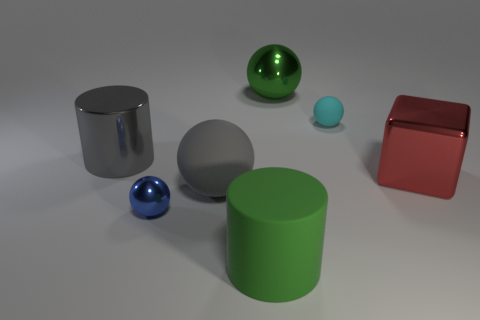Subtract all blue spheres. How many spheres are left? 3 Subtract all green spheres. How many spheres are left? 3 Subtract 1 cylinders. How many cylinders are left? 1 Subtract all blocks. How many objects are left? 6 Add 2 red matte things. How many objects exist? 9 Subtract all red cylinders. How many green spheres are left? 1 Subtract all large green spheres. Subtract all large rubber balls. How many objects are left? 5 Add 6 gray matte things. How many gray matte things are left? 7 Add 6 gray rubber balls. How many gray rubber balls exist? 7 Subtract 1 green cylinders. How many objects are left? 6 